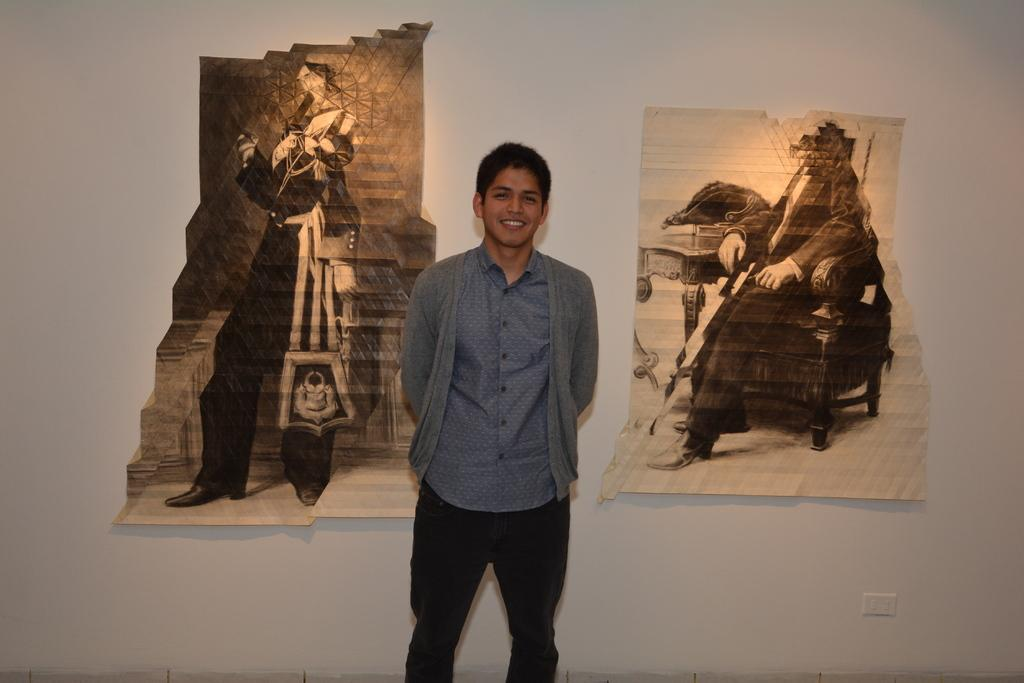Who is present in the image? There is a man in the image. What is the man doing in the image? The man is smiling in the image. What can be seen on the wall in the image? There are posters on the wall in the image. What is the color of the wall in the image? The wall is white in color. What is the man wearing on his upper body in the image? The man is wearing a blue shirt and a coat over the shirt in the image. What type of attack is being carried out by the church in the image? There is no church or attack present in the image; it features a man with a smile and posters on a white wall. Who is delivering the parcel to the man in the image? There is no parcel or delivery person present in the image. 